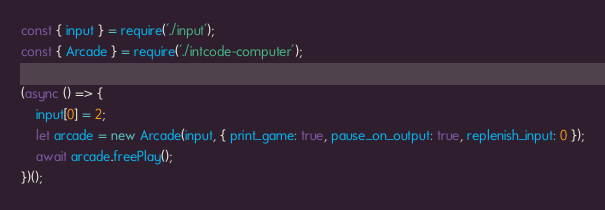Convert code to text. <code><loc_0><loc_0><loc_500><loc_500><_JavaScript_>const { input } = require('./input');
const { Arcade } = require('./intcode-computer');

(async () => {
	input[0] = 2;
	let arcade = new Arcade(input, { print_game: true, pause_on_output: true, replenish_input: 0 });
	await arcade.freePlay();
})();
</code> 